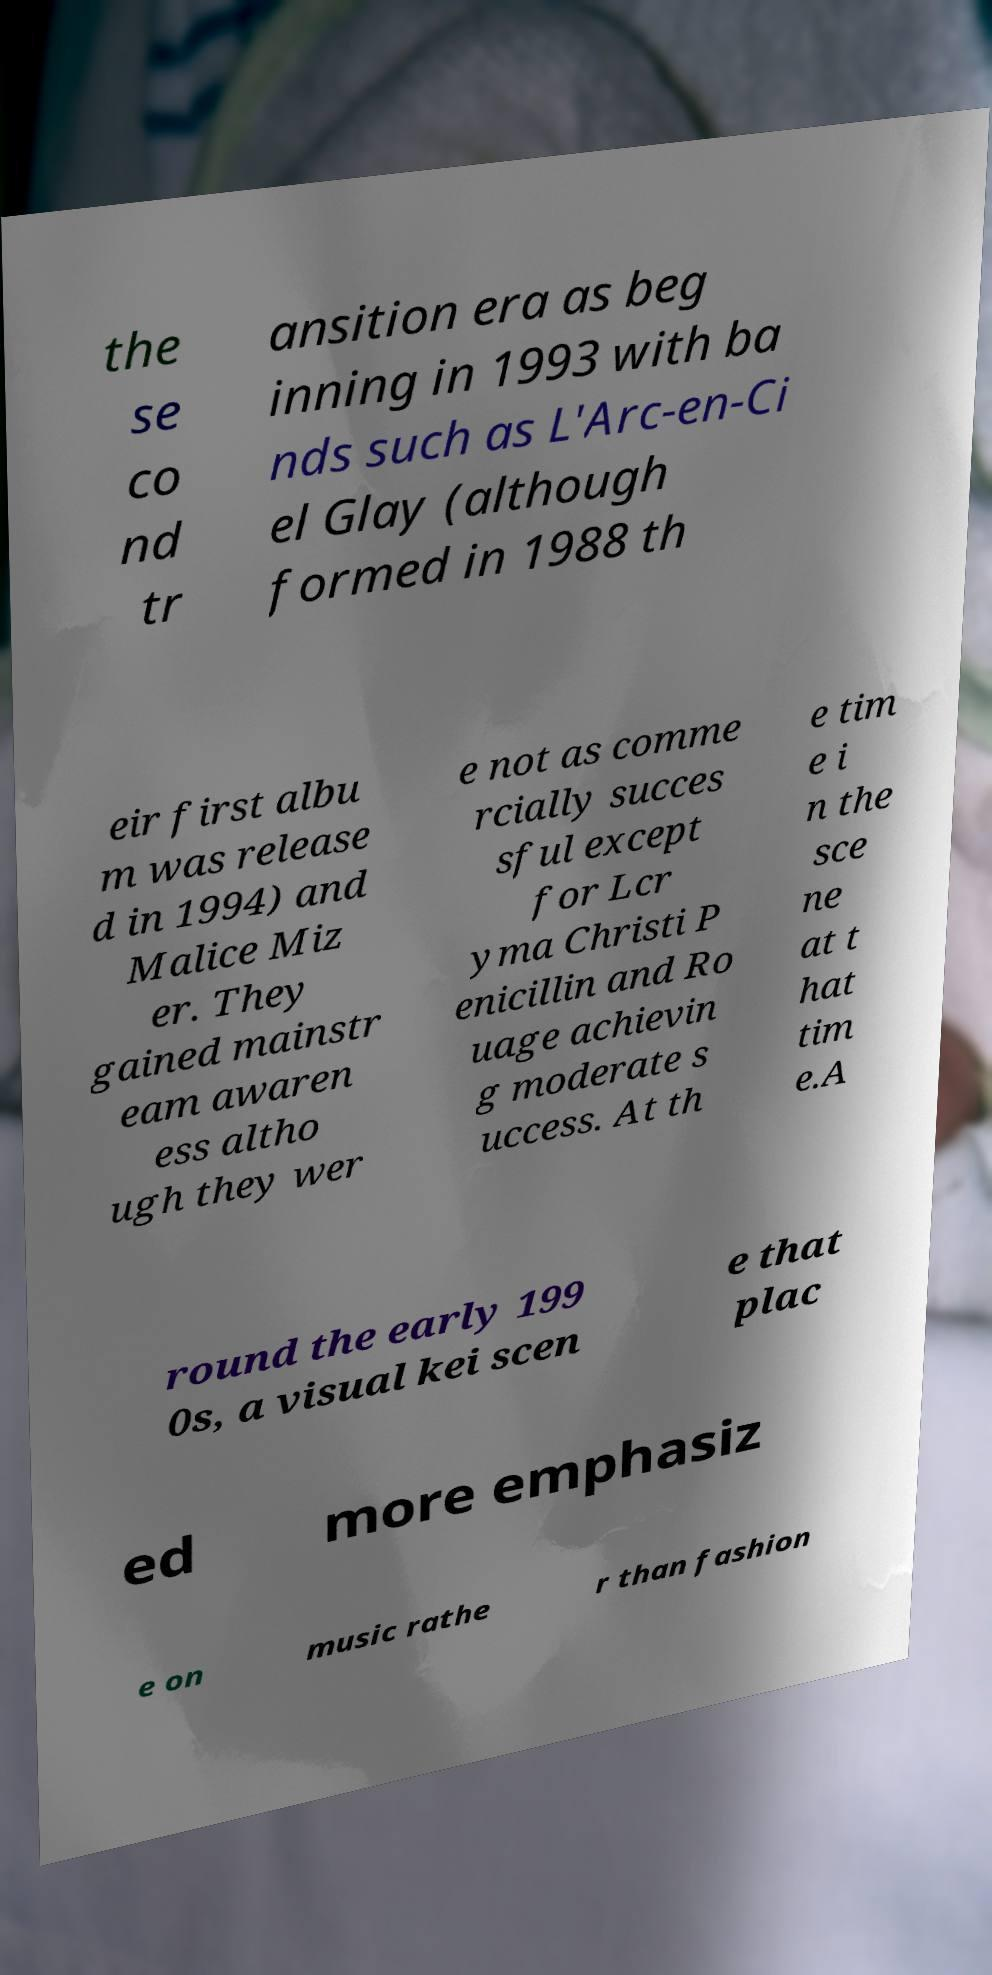Can you accurately transcribe the text from the provided image for me? the se co nd tr ansition era as beg inning in 1993 with ba nds such as L'Arc-en-Ci el Glay (although formed in 1988 th eir first albu m was release d in 1994) and Malice Miz er. They gained mainstr eam awaren ess altho ugh they wer e not as comme rcially succes sful except for Lcr yma Christi P enicillin and Ro uage achievin g moderate s uccess. At th e tim e i n the sce ne at t hat tim e.A round the early 199 0s, a visual kei scen e that plac ed more emphasiz e on music rathe r than fashion 